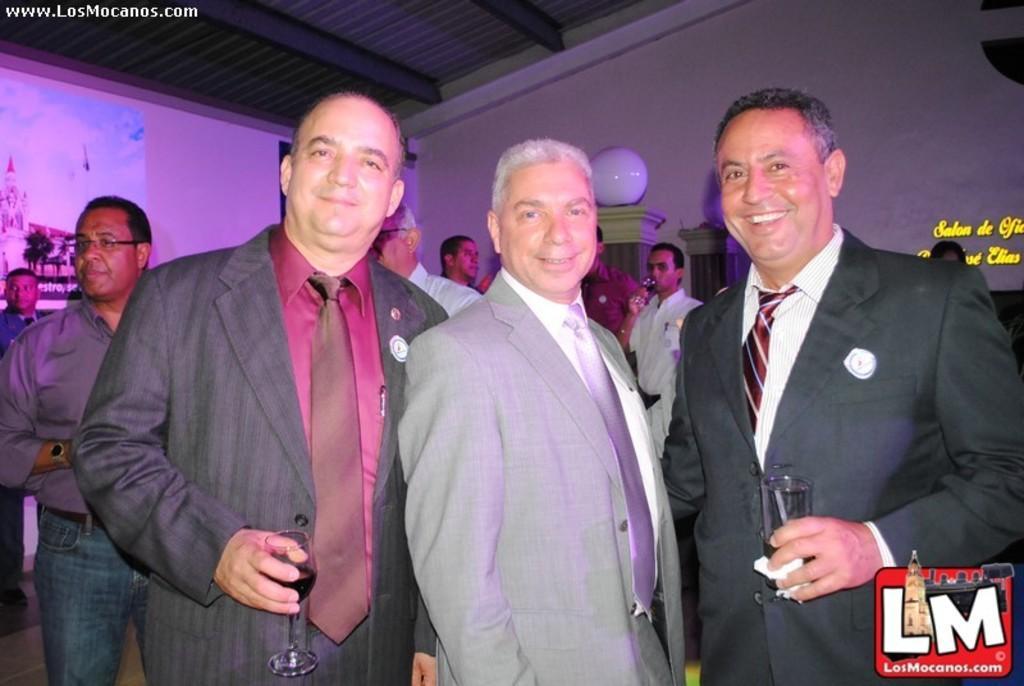Please provide a concise description of this image. In this image we can see a group of people standing. In that some are holding the glasses. On the backside we can see the picture and some text on a wall, a lamp on a pillar and a roof. 